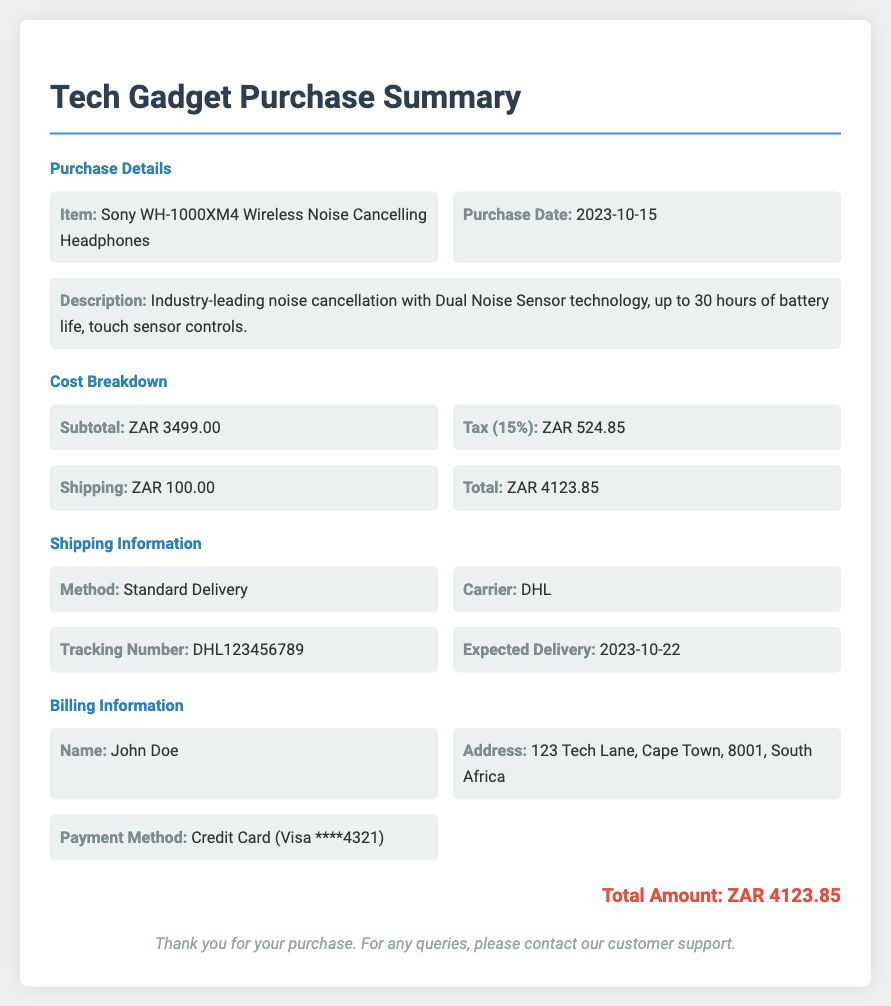What is the item purchased? The item purchased is clearly stated in the document under "Item:" in the Purchase Details section.
Answer: Sony WH-1000XM4 Wireless Noise Cancelling Headphones What is the subtotal of the order? The subtotal is listed in the Cost Breakdown section as the cost before tax and shipping.
Answer: ZAR 3499.00 What is the shipping cost? The shipping cost is mentioned in the Cost Breakdown section, detailing the additional charge for delivery.
Answer: ZAR 100.00 What is the tax applied? The tax amount can be found in the Cost Breakdown section and shows the total tax charged for the order.
Answer: ZAR 524.85 What is the expected delivery date? The expected delivery date is specified in the Shipping Information section and tells when the package will arrive.
Answer: 2023-10-22 Who is the carrier for shipping? The carrier for shipping is provided in the Shipping Information section, indicating which company is responsible for the delivery.
Answer: DHL What payment method was used? The payment method can be found in the Billing Information section, revealing how the transaction was completed.
Answer: Credit Card (Visa ****4321) What is the total amount for the order? The total amount is presented at the end of the document, summing up all charges including item cost, tax, and shipping.
Answer: ZAR 4123.85 What was the purchase date? The purchase date is recorded in the Purchase Details section, indicating when the order was placed.
Answer: 2023-10-15 